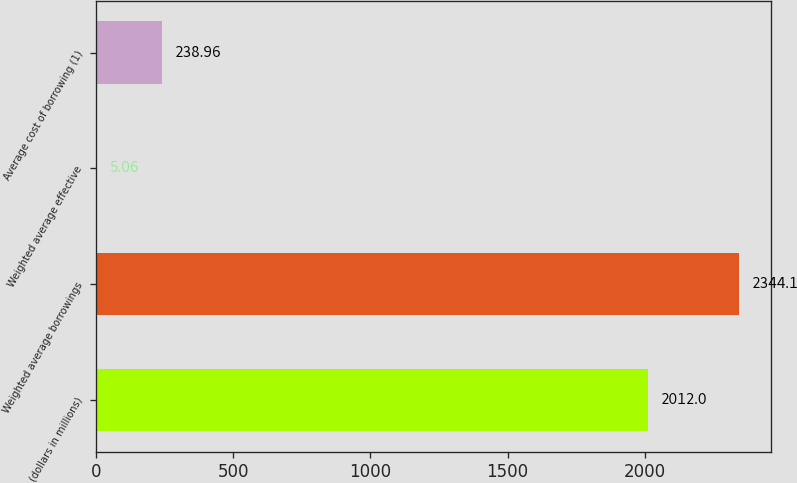Convert chart. <chart><loc_0><loc_0><loc_500><loc_500><bar_chart><fcel>(dollars in millions)<fcel>Weighted average borrowings<fcel>Weighted average effective<fcel>Average cost of borrowing (1)<nl><fcel>2012<fcel>2344.1<fcel>5.06<fcel>238.96<nl></chart> 